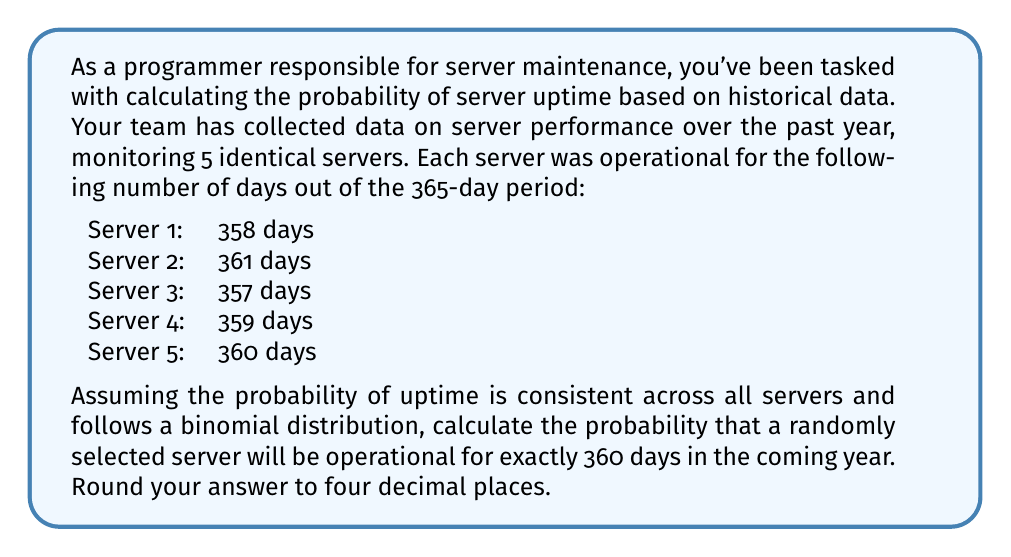Can you solve this math problem? To solve this problem, we'll use the binomial probability formula and the given data to estimate the probability of success (server being operational on any given day).

Step 1: Calculate the average uptime across all servers.
Average uptime = $\frac{358 + 361 + 357 + 359 + 360}{5} = 359$ days

Step 2: Estimate the probability of success (p) for a single day.
$p = \frac{359}{365} \approx 0.9836$

Step 3: Calculate the probability of failure (q) for a single day.
$q = 1 - p \approx 0.0164$

Step 4: Use the binomial probability formula to calculate the probability of exactly 360 successes in 365 trials.

The binomial probability formula is:

$$ P(X = k) = \binom{n}{k} p^k (1-p)^{n-k} $$

Where:
$n$ = number of trials (365 days)
$k$ = number of successes (360 days)
$p$ = probability of success on a single trial (0.9836)

Plugging in the values:

$$ P(X = 360) = \binom{365}{360} (0.9836)^{360} (0.0164)^{5} $$

Step 5: Calculate the binomial coefficient:

$$ \binom{365}{360} = \frac{365!}{360!(365-360)!} = \frac{365!}{360!5!} \approx 5,949,147,431 $$

Step 6: Compute the final probability:

$$ P(X = 360) \approx 5,949,147,431 \times (0.9836)^{360} \times (0.0164)^{5} \approx 0.1839 $$

Step 7: Round the result to four decimal places:

$$ P(X = 360) \approx 0.1839 $$
Answer: 0.1839 